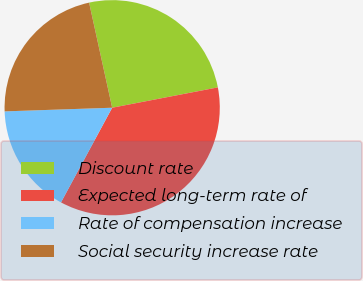Convert chart. <chart><loc_0><loc_0><loc_500><loc_500><pie_chart><fcel>Discount rate<fcel>Expected long-term rate of<fcel>Rate of compensation increase<fcel>Social security increase rate<nl><fcel>25.41%<fcel>35.91%<fcel>16.57%<fcel>22.1%<nl></chart> 